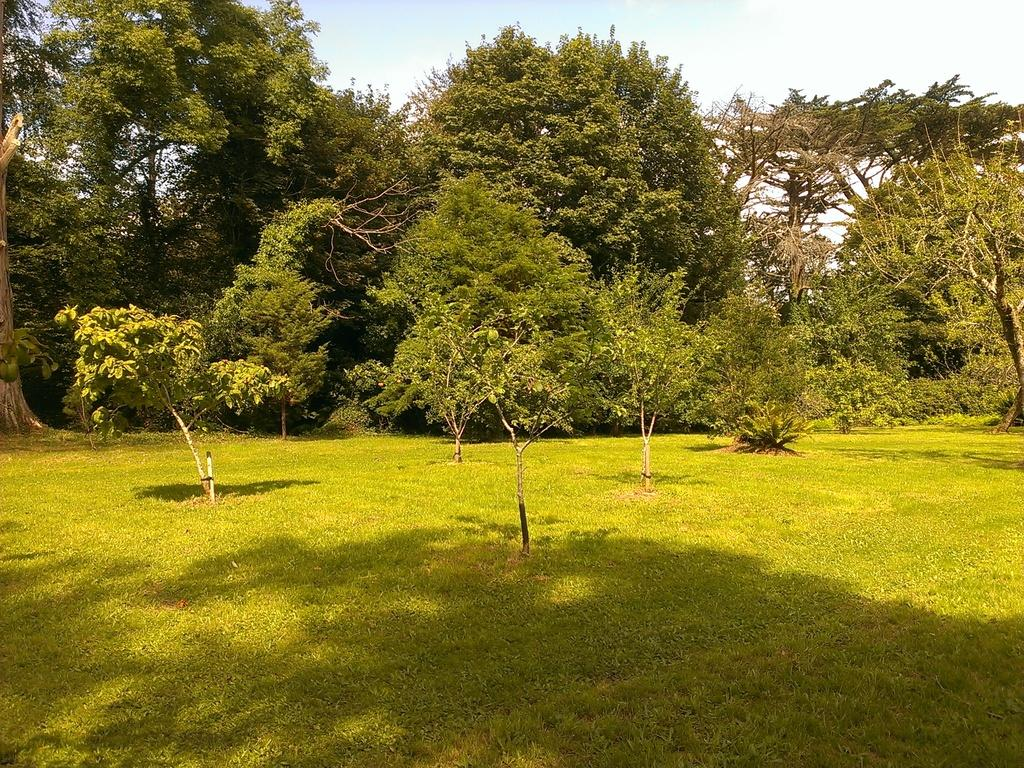What type of surface is visible in the image? There is a grass surface in the image. What is present on the grass surface? There are plants on the grass surface. What can be seen in the background of the image? There are trees visible in the background of the image. What is visible above the grass surface and trees? The sky is visible in the image. What can be observed in the sky? Clouds are present in the sky. What type of room is visible in the image? There is no room present in the image; it features a grass surface, plants, trees, and the sky. Is there a fight happening between the plants in the image? There is no fight depicted in the image; it shows plants on a grass surface. 